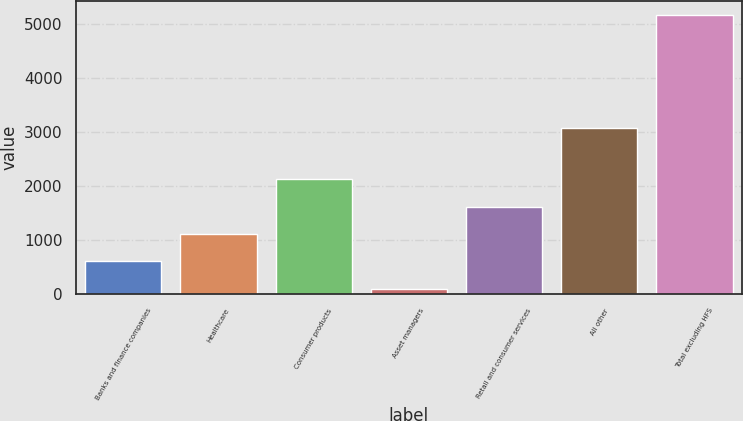<chart> <loc_0><loc_0><loc_500><loc_500><bar_chart><fcel>Banks and finance companies<fcel>Healthcare<fcel>Consumer products<fcel>Asset managers<fcel>Retail and consumer services<fcel>All other<fcel>Total excluding HFS<nl><fcel>609.9<fcel>1116.8<fcel>2130.6<fcel>103<fcel>1623.7<fcel>3081<fcel>5172<nl></chart> 